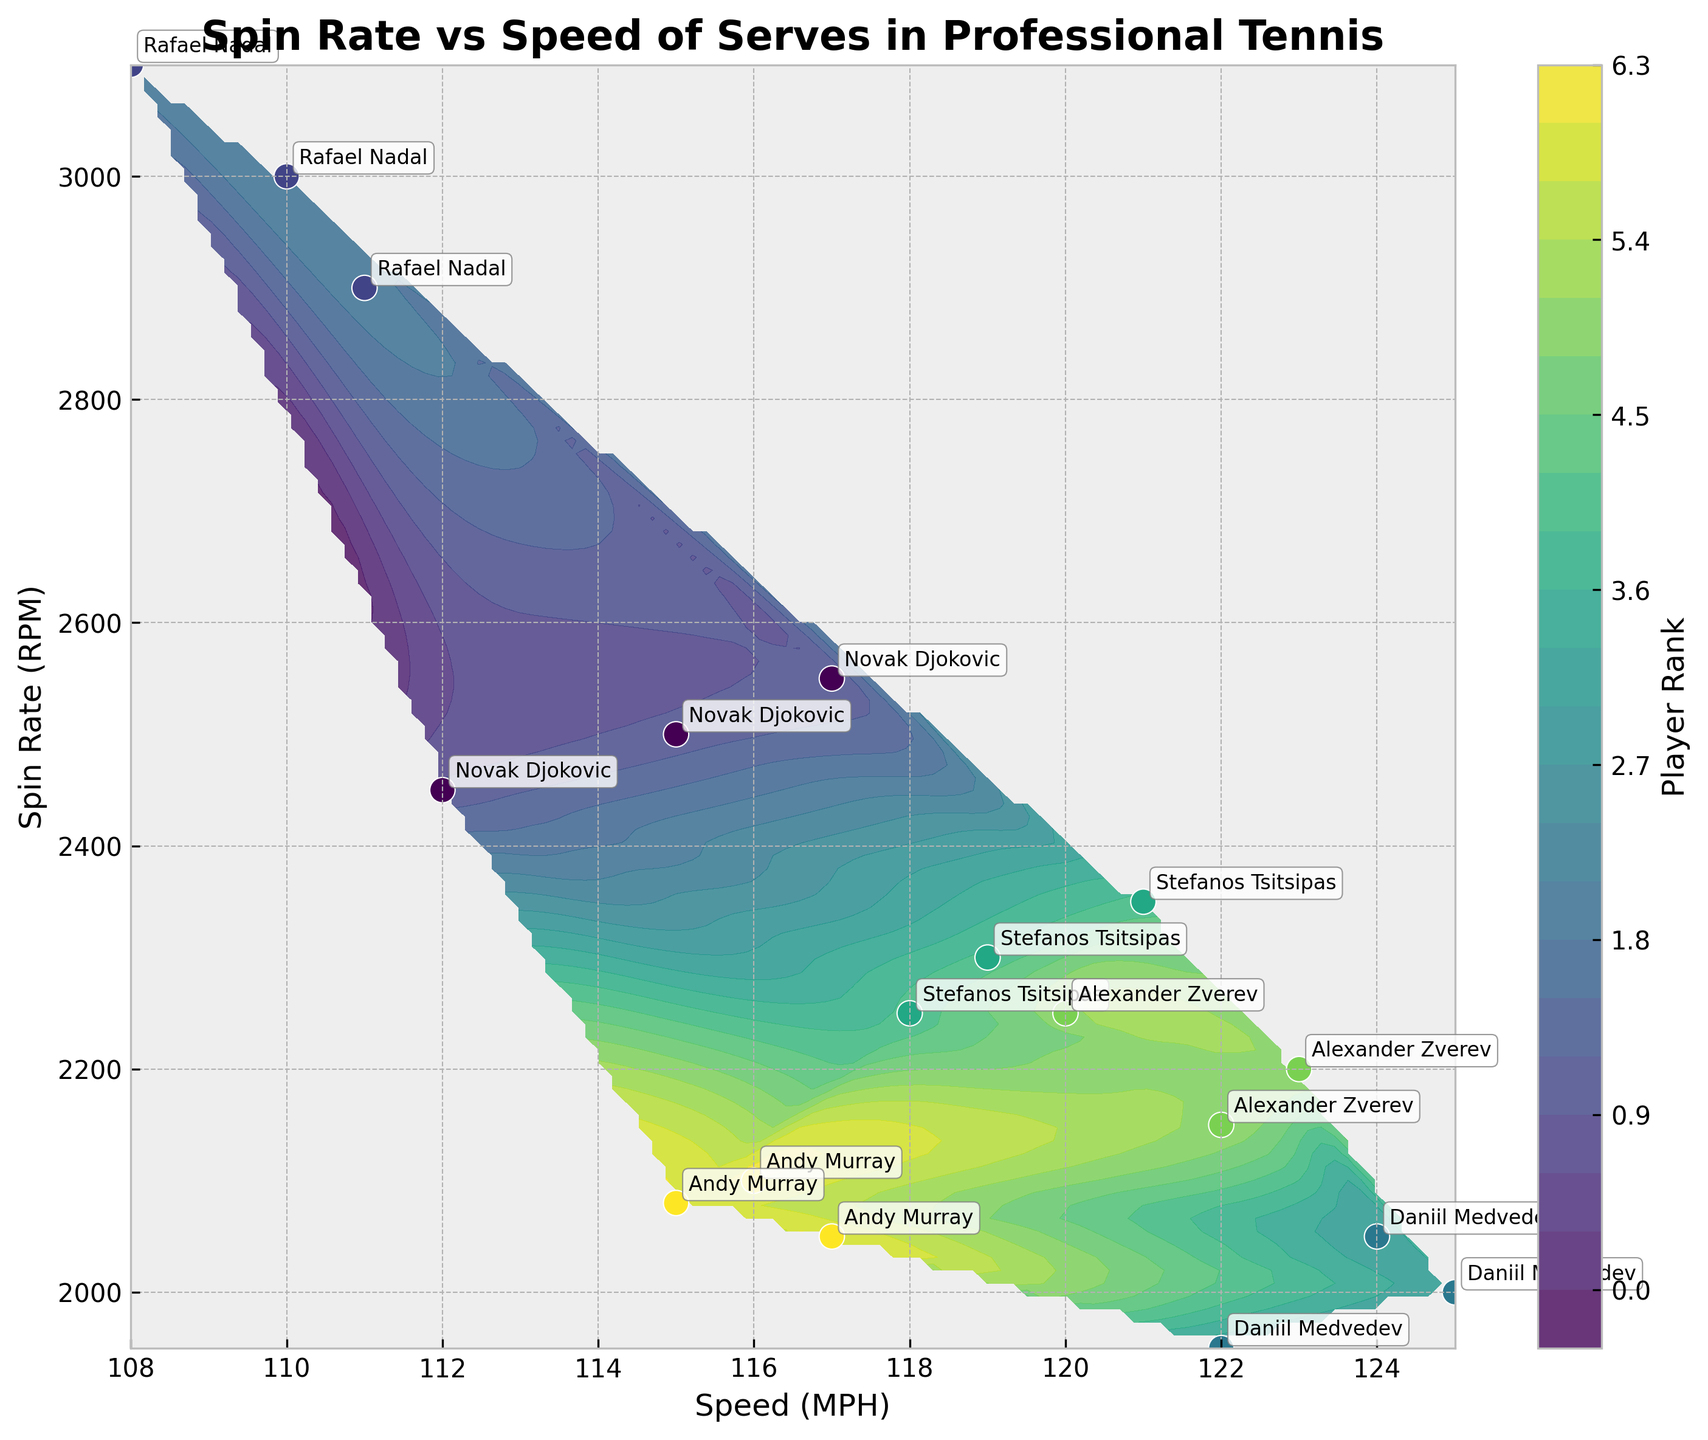What is the title of the plot? The title is displayed at the top of the figure.
Answer: Spin Rate vs Speed of Serves in Professional Tennis What are the labels for the x-axis and y-axis? The labels can be found along the respective axes. The x-axis is labeled "Speed (MPH)" and the y-axis is labeled "Spin Rate (RPM)".
Answer: Speed (MPH); Spin Rate (RPM) Which player has the highest spin rate? Check the y-axis to identify the highest spin rate data point and then look at the annotation to find the player's name. The highest spin rate corresponds to Rafael Nadal with a value of 3100 RPM.
Answer: Rafael Nadal What is the color of the colorbar and what does it represent? Observing the colorbar on the right side of the plot, it displays a gradient from light to dark shades, and it represents the player rankings.
Answer: Gradient shades; Player Rank Which player has the lowest speed of serve? Identify the lowest x-axis value and find the corresponding annotation. The lowest speed of serve is for Rafael Nadal with a speed around 108 MPH.
Answer: Rafael Nadal Compare the spin rate of Novak Djokovic and Andy Murray. Who has higher values overall? Observing the scatter points labeled with their names, Novak Djokovic has spin rate values ranging around 2450-2550 RPM while Andy Murray's spin rates range around 2050-2100 RPM.
Answer: Novak Djokovic What speed and spin rate ranges are covered by the contour plot? Look at the extents of the x and y axes. The speed ranges from approximately 108 to 125 MPH, and the spin rate ranges from approximately 1950 to 3100 RPM.
Answer: 108 to 125 MPH; 1950 to 3100 RPM How does the spin rate trend with speed for player-ranked 3? Analyze the scatter points labeled "Daniil Medvedev" and determine the relationship. Rank 3 player Daniil Medvedev's spin rate is relatively low but increases as speed approaches 125 MPH.
Answer: Increases slightly with speed What general relationship can be observed between player rankings and serve speed? By assessing the color-coded data points, we can note that higher-ranked players generally tend to cluster around lower serve speeds.
Answer: Higher-ranked players cluster at lower serve speeds What ranking tends to have the highest average spin rates based on the contour plot? By examining the color bar and data clusters, it appears that players ranked 1 and 2 (deeper color shades) are associated with higher average spin rates.
Answer: Rank 1 and 2 